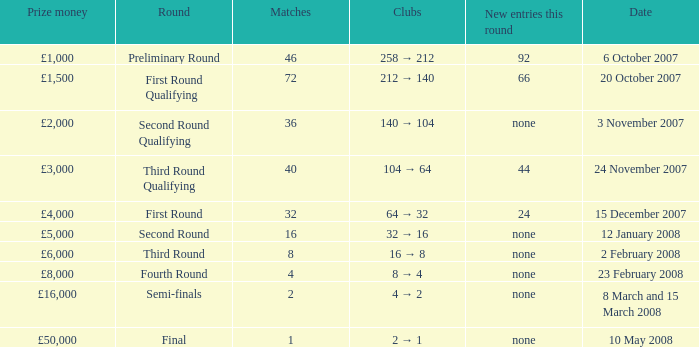What are the clubs with 46 matches? 258 → 212. 